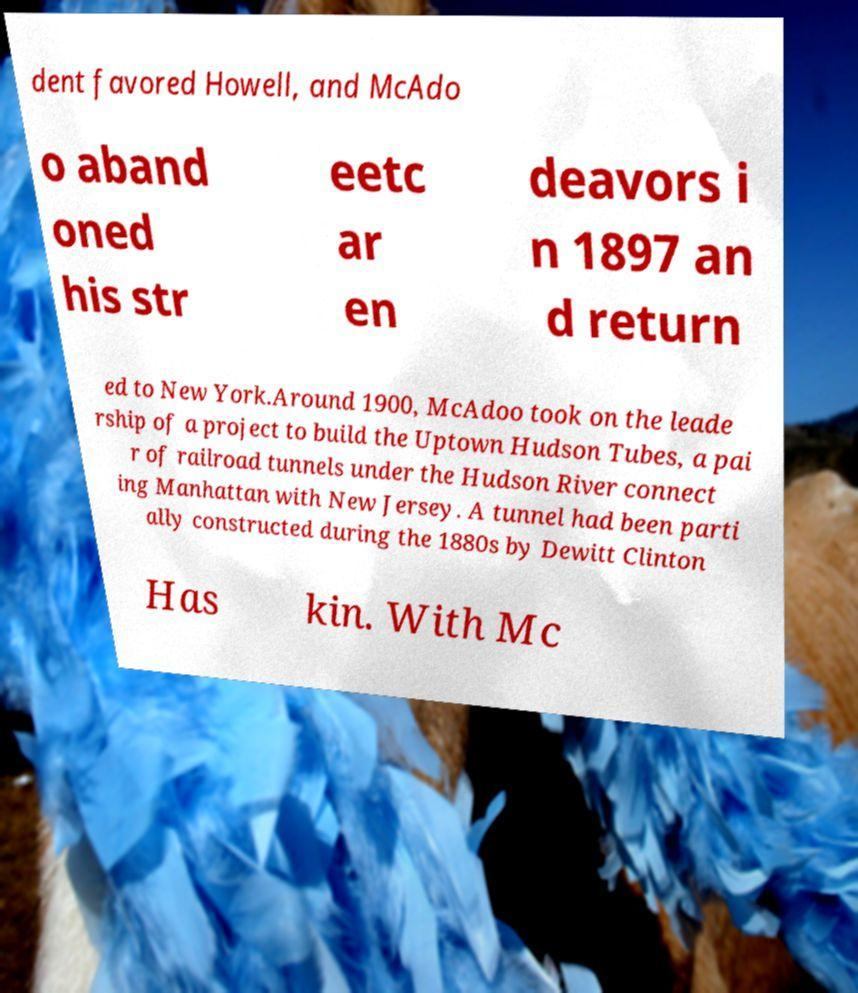What messages or text are displayed in this image? I need them in a readable, typed format. dent favored Howell, and McAdo o aband oned his str eetc ar en deavors i n 1897 an d return ed to New York.Around 1900, McAdoo took on the leade rship of a project to build the Uptown Hudson Tubes, a pai r of railroad tunnels under the Hudson River connect ing Manhattan with New Jersey. A tunnel had been parti ally constructed during the 1880s by Dewitt Clinton Has kin. With Mc 